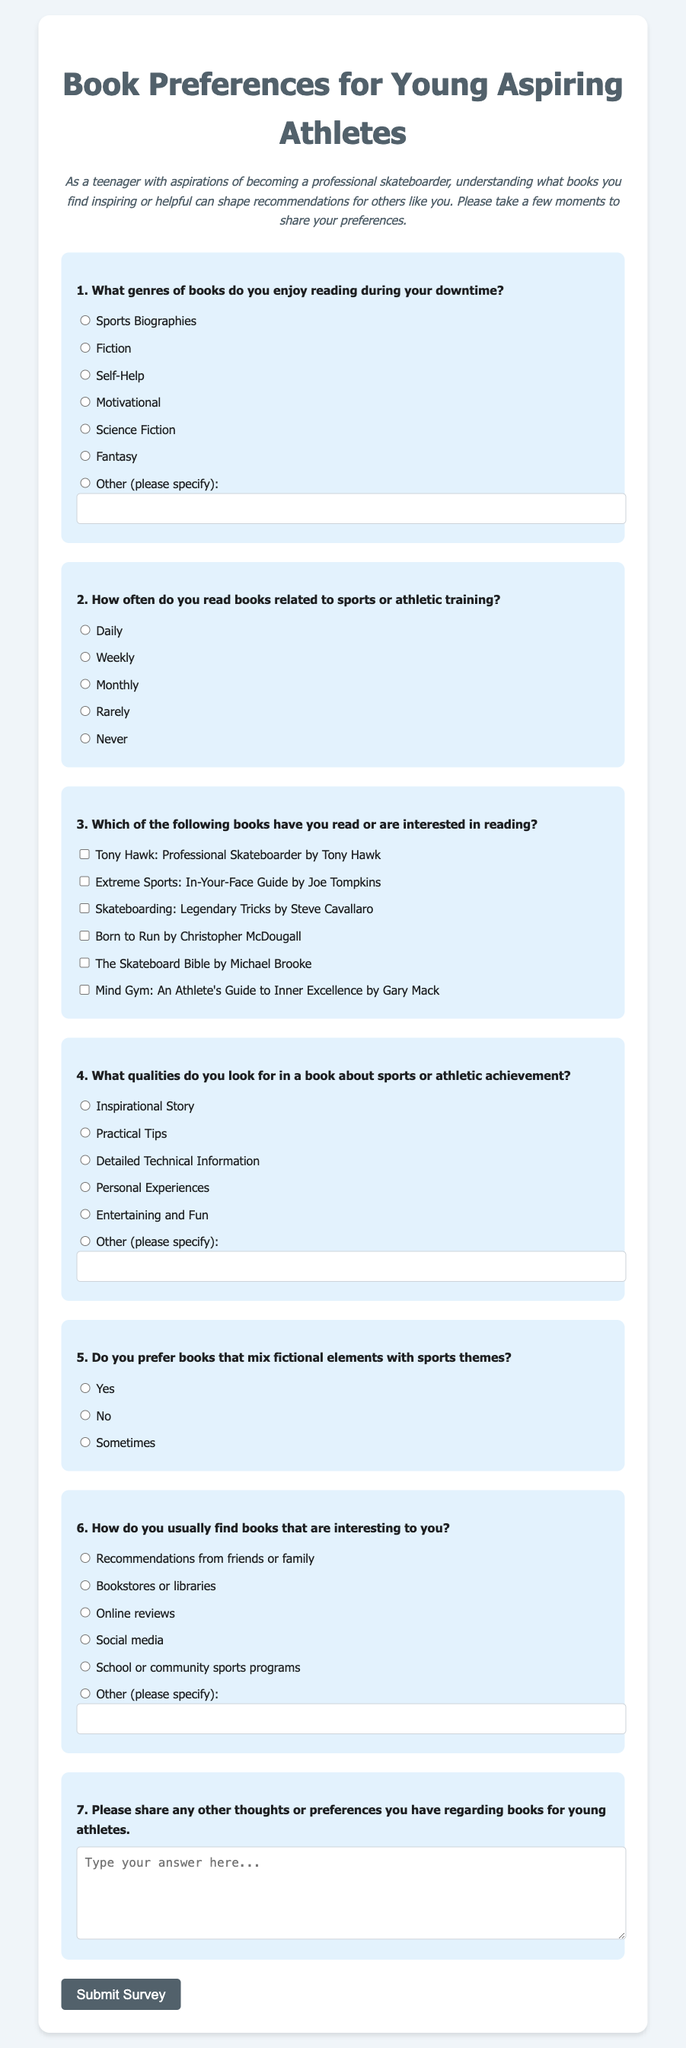What is the title of the survey? The title of the survey is prominently displayed at the top of the document, indicating the main focus of the survey.
Answer: Book Preferences for Young Aspiring Athletes How many questions are included in the survey? The survey consists of a series of questions aimed at gathering preferences from participants, specifically detailing how many are included.
Answer: Seven What type of books is listed as an option in question one? Question one provides multiple genres of books, including several options for participants to select from.
Answer: Sports Biographies Which book is associated with the author Tony Hawk? The survey includes specific book titles along with their authors, allowing participants to indicate their familiarity with them.
Answer: Tony Hawk: Professional Skateboarder What are the options for the frequency of reading sports-related books? Question two asks participants how often they engage with sports-related literature, and provides a set of possible responses based on frequency.
Answer: Daily, Weekly, Monthly, Rarely, Never What qualities are mentioned in question four that participants might look for in a sports book? The significance of qualities in sports literature is highlighted in the survey, where participants can choose one that resonates with them.
Answer: Inspirational Story, Practical Tips, Detailed Technical Information, Personal Experiences, Entertaining and Fun How can participants submit their responses? The end of the survey features a button that allows respondents to complete their participation, which emphasizes the completion process.
Answer: Submit Survey 